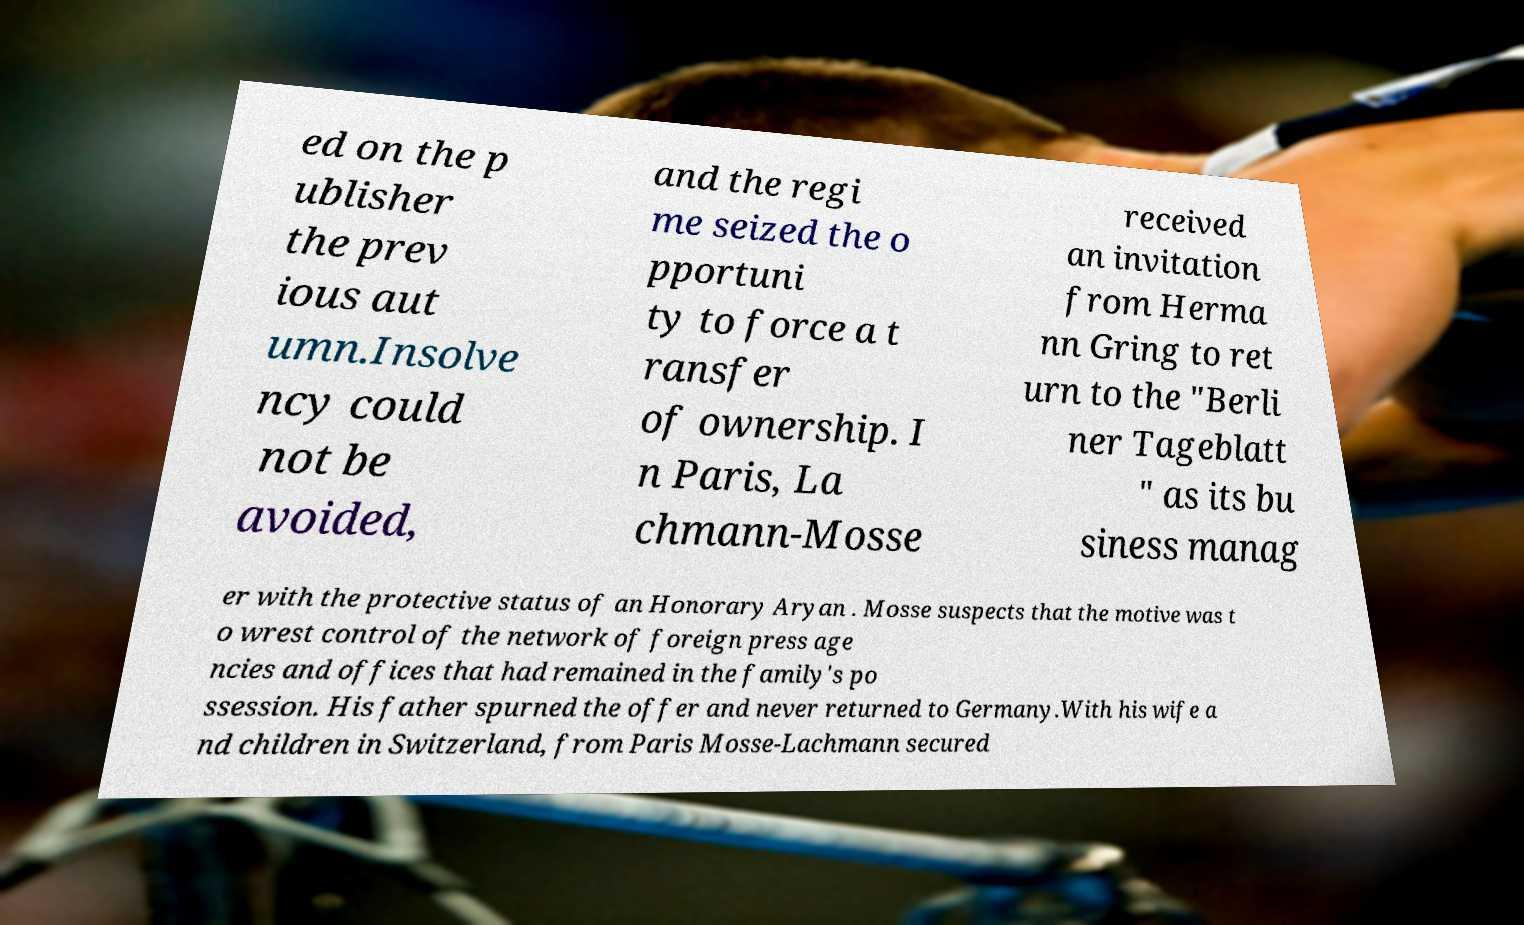Can you read and provide the text displayed in the image?This photo seems to have some interesting text. Can you extract and type it out for me? ed on the p ublisher the prev ious aut umn.Insolve ncy could not be avoided, and the regi me seized the o pportuni ty to force a t ransfer of ownership. I n Paris, La chmann-Mosse received an invitation from Herma nn Gring to ret urn to the "Berli ner Tageblatt " as its bu siness manag er with the protective status of an Honorary Aryan . Mosse suspects that the motive was t o wrest control of the network of foreign press age ncies and offices that had remained in the family's po ssession. His father spurned the offer and never returned to Germany.With his wife a nd children in Switzerland, from Paris Mosse-Lachmann secured 